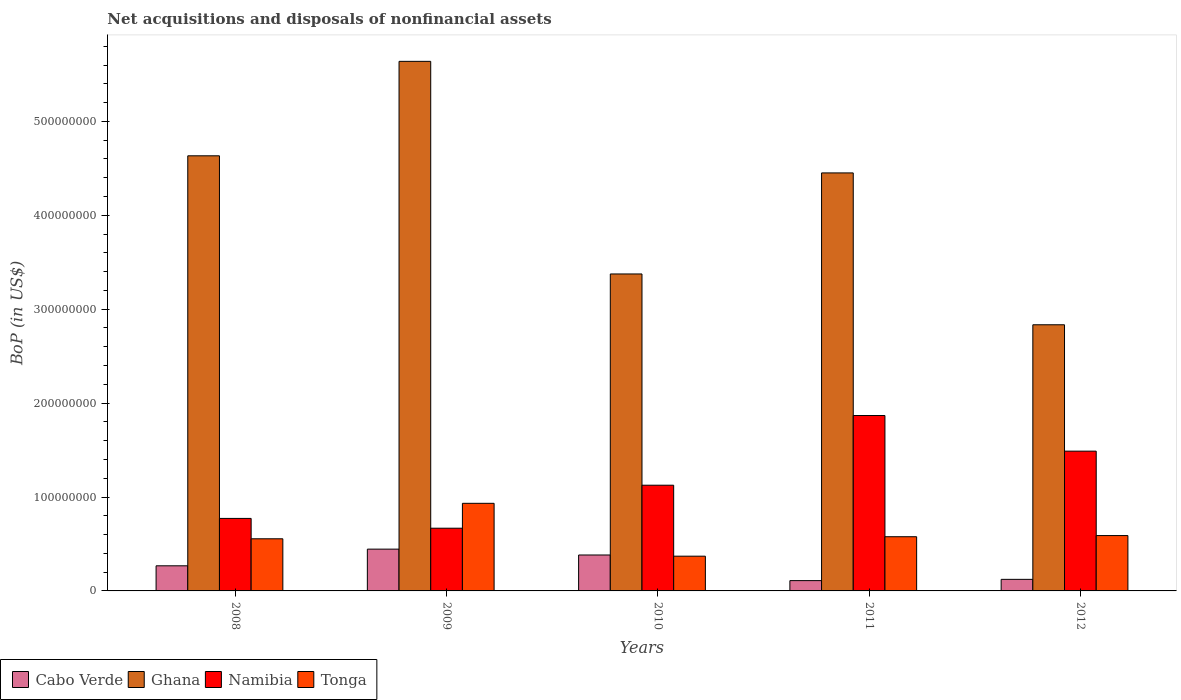How many groups of bars are there?
Your answer should be very brief. 5. How many bars are there on the 3rd tick from the left?
Your response must be concise. 4. How many bars are there on the 2nd tick from the right?
Provide a short and direct response. 4. In how many cases, is the number of bars for a given year not equal to the number of legend labels?
Provide a short and direct response. 0. What is the Balance of Payments in Tonga in 2009?
Give a very brief answer. 9.33e+07. Across all years, what is the maximum Balance of Payments in Cabo Verde?
Provide a succinct answer. 4.45e+07. Across all years, what is the minimum Balance of Payments in Tonga?
Your answer should be very brief. 3.70e+07. What is the total Balance of Payments in Cabo Verde in the graph?
Keep it short and to the point. 1.33e+08. What is the difference between the Balance of Payments in Tonga in 2009 and that in 2011?
Your response must be concise. 3.56e+07. What is the difference between the Balance of Payments in Tonga in 2010 and the Balance of Payments in Namibia in 2009?
Provide a short and direct response. -2.98e+07. What is the average Balance of Payments in Namibia per year?
Provide a short and direct response. 1.18e+08. In the year 2012, what is the difference between the Balance of Payments in Tonga and Balance of Payments in Namibia?
Provide a succinct answer. -8.99e+07. What is the ratio of the Balance of Payments in Namibia in 2008 to that in 2011?
Provide a short and direct response. 0.41. Is the Balance of Payments in Namibia in 2008 less than that in 2009?
Offer a terse response. No. What is the difference between the highest and the second highest Balance of Payments in Cabo Verde?
Provide a short and direct response. 6.24e+06. What is the difference between the highest and the lowest Balance of Payments in Namibia?
Offer a terse response. 1.20e+08. In how many years, is the Balance of Payments in Tonga greater than the average Balance of Payments in Tonga taken over all years?
Give a very brief answer. 1. Is the sum of the Balance of Payments in Cabo Verde in 2009 and 2012 greater than the maximum Balance of Payments in Namibia across all years?
Offer a terse response. No. Is it the case that in every year, the sum of the Balance of Payments in Cabo Verde and Balance of Payments in Namibia is greater than the sum of Balance of Payments in Ghana and Balance of Payments in Tonga?
Ensure brevity in your answer.  No. What does the 3rd bar from the left in 2010 represents?
Provide a short and direct response. Namibia. What does the 4th bar from the right in 2008 represents?
Your answer should be compact. Cabo Verde. How many bars are there?
Offer a very short reply. 20. Does the graph contain grids?
Provide a succinct answer. No. Where does the legend appear in the graph?
Your answer should be very brief. Bottom left. How many legend labels are there?
Provide a short and direct response. 4. How are the legend labels stacked?
Offer a terse response. Horizontal. What is the title of the graph?
Your answer should be very brief. Net acquisitions and disposals of nonfinancial assets. What is the label or title of the X-axis?
Ensure brevity in your answer.  Years. What is the label or title of the Y-axis?
Give a very brief answer. BoP (in US$). What is the BoP (in US$) of Cabo Verde in 2008?
Your answer should be compact. 2.67e+07. What is the BoP (in US$) of Ghana in 2008?
Your answer should be very brief. 4.63e+08. What is the BoP (in US$) of Namibia in 2008?
Your answer should be very brief. 7.72e+07. What is the BoP (in US$) in Tonga in 2008?
Provide a short and direct response. 5.55e+07. What is the BoP (in US$) in Cabo Verde in 2009?
Offer a terse response. 4.45e+07. What is the BoP (in US$) of Ghana in 2009?
Offer a very short reply. 5.64e+08. What is the BoP (in US$) in Namibia in 2009?
Give a very brief answer. 6.68e+07. What is the BoP (in US$) in Tonga in 2009?
Provide a short and direct response. 9.33e+07. What is the BoP (in US$) in Cabo Verde in 2010?
Keep it short and to the point. 3.83e+07. What is the BoP (in US$) of Ghana in 2010?
Your response must be concise. 3.38e+08. What is the BoP (in US$) in Namibia in 2010?
Make the answer very short. 1.13e+08. What is the BoP (in US$) in Tonga in 2010?
Offer a terse response. 3.70e+07. What is the BoP (in US$) of Cabo Verde in 2011?
Make the answer very short. 1.10e+07. What is the BoP (in US$) in Ghana in 2011?
Make the answer very short. 4.45e+08. What is the BoP (in US$) of Namibia in 2011?
Keep it short and to the point. 1.87e+08. What is the BoP (in US$) of Tonga in 2011?
Give a very brief answer. 5.77e+07. What is the BoP (in US$) in Cabo Verde in 2012?
Your answer should be compact. 1.23e+07. What is the BoP (in US$) in Ghana in 2012?
Your answer should be compact. 2.83e+08. What is the BoP (in US$) of Namibia in 2012?
Offer a terse response. 1.49e+08. What is the BoP (in US$) of Tonga in 2012?
Your response must be concise. 5.89e+07. Across all years, what is the maximum BoP (in US$) of Cabo Verde?
Keep it short and to the point. 4.45e+07. Across all years, what is the maximum BoP (in US$) of Ghana?
Your answer should be very brief. 5.64e+08. Across all years, what is the maximum BoP (in US$) of Namibia?
Provide a short and direct response. 1.87e+08. Across all years, what is the maximum BoP (in US$) in Tonga?
Make the answer very short. 9.33e+07. Across all years, what is the minimum BoP (in US$) in Cabo Verde?
Your answer should be very brief. 1.10e+07. Across all years, what is the minimum BoP (in US$) in Ghana?
Provide a succinct answer. 2.83e+08. Across all years, what is the minimum BoP (in US$) in Namibia?
Provide a succinct answer. 6.68e+07. Across all years, what is the minimum BoP (in US$) of Tonga?
Your response must be concise. 3.70e+07. What is the total BoP (in US$) of Cabo Verde in the graph?
Your answer should be compact. 1.33e+08. What is the total BoP (in US$) in Ghana in the graph?
Make the answer very short. 2.09e+09. What is the total BoP (in US$) of Namibia in the graph?
Keep it short and to the point. 5.92e+08. What is the total BoP (in US$) of Tonga in the graph?
Your answer should be compact. 3.02e+08. What is the difference between the BoP (in US$) in Cabo Verde in 2008 and that in 2009?
Keep it short and to the point. -1.77e+07. What is the difference between the BoP (in US$) in Ghana in 2008 and that in 2009?
Give a very brief answer. -1.01e+08. What is the difference between the BoP (in US$) of Namibia in 2008 and that in 2009?
Offer a terse response. 1.04e+07. What is the difference between the BoP (in US$) in Tonga in 2008 and that in 2009?
Give a very brief answer. -3.78e+07. What is the difference between the BoP (in US$) of Cabo Verde in 2008 and that in 2010?
Ensure brevity in your answer.  -1.15e+07. What is the difference between the BoP (in US$) of Ghana in 2008 and that in 2010?
Your answer should be compact. 1.26e+08. What is the difference between the BoP (in US$) of Namibia in 2008 and that in 2010?
Offer a terse response. -3.54e+07. What is the difference between the BoP (in US$) of Tonga in 2008 and that in 2010?
Give a very brief answer. 1.85e+07. What is the difference between the BoP (in US$) of Cabo Verde in 2008 and that in 2011?
Your response must be concise. 1.58e+07. What is the difference between the BoP (in US$) of Ghana in 2008 and that in 2011?
Provide a short and direct response. 1.82e+07. What is the difference between the BoP (in US$) in Namibia in 2008 and that in 2011?
Provide a short and direct response. -1.10e+08. What is the difference between the BoP (in US$) of Tonga in 2008 and that in 2011?
Make the answer very short. -2.19e+06. What is the difference between the BoP (in US$) in Cabo Verde in 2008 and that in 2012?
Your answer should be very brief. 1.44e+07. What is the difference between the BoP (in US$) of Ghana in 2008 and that in 2012?
Provide a short and direct response. 1.80e+08. What is the difference between the BoP (in US$) in Namibia in 2008 and that in 2012?
Offer a terse response. -7.16e+07. What is the difference between the BoP (in US$) in Tonga in 2008 and that in 2012?
Ensure brevity in your answer.  -3.43e+06. What is the difference between the BoP (in US$) in Cabo Verde in 2009 and that in 2010?
Ensure brevity in your answer.  6.24e+06. What is the difference between the BoP (in US$) in Ghana in 2009 and that in 2010?
Give a very brief answer. 2.26e+08. What is the difference between the BoP (in US$) in Namibia in 2009 and that in 2010?
Ensure brevity in your answer.  -4.58e+07. What is the difference between the BoP (in US$) in Tonga in 2009 and that in 2010?
Offer a very short reply. 5.63e+07. What is the difference between the BoP (in US$) in Cabo Verde in 2009 and that in 2011?
Keep it short and to the point. 3.35e+07. What is the difference between the BoP (in US$) in Ghana in 2009 and that in 2011?
Make the answer very short. 1.19e+08. What is the difference between the BoP (in US$) of Namibia in 2009 and that in 2011?
Your answer should be compact. -1.20e+08. What is the difference between the BoP (in US$) in Tonga in 2009 and that in 2011?
Ensure brevity in your answer.  3.56e+07. What is the difference between the BoP (in US$) of Cabo Verde in 2009 and that in 2012?
Offer a terse response. 3.22e+07. What is the difference between the BoP (in US$) of Ghana in 2009 and that in 2012?
Ensure brevity in your answer.  2.80e+08. What is the difference between the BoP (in US$) of Namibia in 2009 and that in 2012?
Provide a short and direct response. -8.21e+07. What is the difference between the BoP (in US$) in Tonga in 2009 and that in 2012?
Your response must be concise. 3.43e+07. What is the difference between the BoP (in US$) of Cabo Verde in 2010 and that in 2011?
Your answer should be very brief. 2.73e+07. What is the difference between the BoP (in US$) of Ghana in 2010 and that in 2011?
Your answer should be compact. -1.08e+08. What is the difference between the BoP (in US$) in Namibia in 2010 and that in 2011?
Your answer should be very brief. -7.42e+07. What is the difference between the BoP (in US$) of Tonga in 2010 and that in 2011?
Your response must be concise. -2.07e+07. What is the difference between the BoP (in US$) in Cabo Verde in 2010 and that in 2012?
Keep it short and to the point. 2.59e+07. What is the difference between the BoP (in US$) in Ghana in 2010 and that in 2012?
Your response must be concise. 5.41e+07. What is the difference between the BoP (in US$) in Namibia in 2010 and that in 2012?
Offer a terse response. -3.63e+07. What is the difference between the BoP (in US$) in Tonga in 2010 and that in 2012?
Make the answer very short. -2.20e+07. What is the difference between the BoP (in US$) of Cabo Verde in 2011 and that in 2012?
Give a very brief answer. -1.35e+06. What is the difference between the BoP (in US$) in Ghana in 2011 and that in 2012?
Your answer should be very brief. 1.62e+08. What is the difference between the BoP (in US$) in Namibia in 2011 and that in 2012?
Offer a terse response. 3.79e+07. What is the difference between the BoP (in US$) in Tonga in 2011 and that in 2012?
Offer a terse response. -1.24e+06. What is the difference between the BoP (in US$) of Cabo Verde in 2008 and the BoP (in US$) of Ghana in 2009?
Offer a terse response. -5.37e+08. What is the difference between the BoP (in US$) in Cabo Verde in 2008 and the BoP (in US$) in Namibia in 2009?
Provide a short and direct response. -4.00e+07. What is the difference between the BoP (in US$) in Cabo Verde in 2008 and the BoP (in US$) in Tonga in 2009?
Offer a very short reply. -6.65e+07. What is the difference between the BoP (in US$) of Ghana in 2008 and the BoP (in US$) of Namibia in 2009?
Ensure brevity in your answer.  3.97e+08. What is the difference between the BoP (in US$) of Ghana in 2008 and the BoP (in US$) of Tonga in 2009?
Offer a terse response. 3.70e+08. What is the difference between the BoP (in US$) in Namibia in 2008 and the BoP (in US$) in Tonga in 2009?
Your response must be concise. -1.61e+07. What is the difference between the BoP (in US$) of Cabo Verde in 2008 and the BoP (in US$) of Ghana in 2010?
Provide a short and direct response. -3.11e+08. What is the difference between the BoP (in US$) in Cabo Verde in 2008 and the BoP (in US$) in Namibia in 2010?
Offer a very short reply. -8.58e+07. What is the difference between the BoP (in US$) of Cabo Verde in 2008 and the BoP (in US$) of Tonga in 2010?
Offer a terse response. -1.02e+07. What is the difference between the BoP (in US$) in Ghana in 2008 and the BoP (in US$) in Namibia in 2010?
Make the answer very short. 3.51e+08. What is the difference between the BoP (in US$) of Ghana in 2008 and the BoP (in US$) of Tonga in 2010?
Make the answer very short. 4.26e+08. What is the difference between the BoP (in US$) of Namibia in 2008 and the BoP (in US$) of Tonga in 2010?
Your answer should be very brief. 4.02e+07. What is the difference between the BoP (in US$) of Cabo Verde in 2008 and the BoP (in US$) of Ghana in 2011?
Give a very brief answer. -4.18e+08. What is the difference between the BoP (in US$) of Cabo Verde in 2008 and the BoP (in US$) of Namibia in 2011?
Provide a succinct answer. -1.60e+08. What is the difference between the BoP (in US$) of Cabo Verde in 2008 and the BoP (in US$) of Tonga in 2011?
Provide a succinct answer. -3.10e+07. What is the difference between the BoP (in US$) of Ghana in 2008 and the BoP (in US$) of Namibia in 2011?
Ensure brevity in your answer.  2.77e+08. What is the difference between the BoP (in US$) in Ghana in 2008 and the BoP (in US$) in Tonga in 2011?
Provide a succinct answer. 4.06e+08. What is the difference between the BoP (in US$) of Namibia in 2008 and the BoP (in US$) of Tonga in 2011?
Give a very brief answer. 1.95e+07. What is the difference between the BoP (in US$) of Cabo Verde in 2008 and the BoP (in US$) of Ghana in 2012?
Your answer should be very brief. -2.57e+08. What is the difference between the BoP (in US$) of Cabo Verde in 2008 and the BoP (in US$) of Namibia in 2012?
Your answer should be compact. -1.22e+08. What is the difference between the BoP (in US$) of Cabo Verde in 2008 and the BoP (in US$) of Tonga in 2012?
Give a very brief answer. -3.22e+07. What is the difference between the BoP (in US$) in Ghana in 2008 and the BoP (in US$) in Namibia in 2012?
Your answer should be very brief. 3.14e+08. What is the difference between the BoP (in US$) of Ghana in 2008 and the BoP (in US$) of Tonga in 2012?
Keep it short and to the point. 4.04e+08. What is the difference between the BoP (in US$) in Namibia in 2008 and the BoP (in US$) in Tonga in 2012?
Offer a very short reply. 1.83e+07. What is the difference between the BoP (in US$) in Cabo Verde in 2009 and the BoP (in US$) in Ghana in 2010?
Offer a terse response. -2.93e+08. What is the difference between the BoP (in US$) of Cabo Verde in 2009 and the BoP (in US$) of Namibia in 2010?
Make the answer very short. -6.81e+07. What is the difference between the BoP (in US$) of Cabo Verde in 2009 and the BoP (in US$) of Tonga in 2010?
Your response must be concise. 7.51e+06. What is the difference between the BoP (in US$) of Ghana in 2009 and the BoP (in US$) of Namibia in 2010?
Provide a short and direct response. 4.51e+08. What is the difference between the BoP (in US$) of Ghana in 2009 and the BoP (in US$) of Tonga in 2010?
Provide a succinct answer. 5.27e+08. What is the difference between the BoP (in US$) in Namibia in 2009 and the BoP (in US$) in Tonga in 2010?
Your answer should be very brief. 2.98e+07. What is the difference between the BoP (in US$) of Cabo Verde in 2009 and the BoP (in US$) of Ghana in 2011?
Offer a terse response. -4.01e+08. What is the difference between the BoP (in US$) in Cabo Verde in 2009 and the BoP (in US$) in Namibia in 2011?
Offer a very short reply. -1.42e+08. What is the difference between the BoP (in US$) in Cabo Verde in 2009 and the BoP (in US$) in Tonga in 2011?
Provide a succinct answer. -1.32e+07. What is the difference between the BoP (in US$) in Ghana in 2009 and the BoP (in US$) in Namibia in 2011?
Offer a very short reply. 3.77e+08. What is the difference between the BoP (in US$) of Ghana in 2009 and the BoP (in US$) of Tonga in 2011?
Your answer should be compact. 5.06e+08. What is the difference between the BoP (in US$) of Namibia in 2009 and the BoP (in US$) of Tonga in 2011?
Provide a short and direct response. 9.07e+06. What is the difference between the BoP (in US$) in Cabo Verde in 2009 and the BoP (in US$) in Ghana in 2012?
Offer a very short reply. -2.39e+08. What is the difference between the BoP (in US$) in Cabo Verde in 2009 and the BoP (in US$) in Namibia in 2012?
Offer a terse response. -1.04e+08. What is the difference between the BoP (in US$) in Cabo Verde in 2009 and the BoP (in US$) in Tonga in 2012?
Offer a terse response. -1.44e+07. What is the difference between the BoP (in US$) of Ghana in 2009 and the BoP (in US$) of Namibia in 2012?
Make the answer very short. 4.15e+08. What is the difference between the BoP (in US$) in Ghana in 2009 and the BoP (in US$) in Tonga in 2012?
Give a very brief answer. 5.05e+08. What is the difference between the BoP (in US$) in Namibia in 2009 and the BoP (in US$) in Tonga in 2012?
Provide a short and direct response. 7.83e+06. What is the difference between the BoP (in US$) in Cabo Verde in 2010 and the BoP (in US$) in Ghana in 2011?
Your answer should be compact. -4.07e+08. What is the difference between the BoP (in US$) in Cabo Verde in 2010 and the BoP (in US$) in Namibia in 2011?
Your response must be concise. -1.49e+08. What is the difference between the BoP (in US$) of Cabo Verde in 2010 and the BoP (in US$) of Tonga in 2011?
Provide a succinct answer. -1.94e+07. What is the difference between the BoP (in US$) of Ghana in 2010 and the BoP (in US$) of Namibia in 2011?
Offer a terse response. 1.51e+08. What is the difference between the BoP (in US$) in Ghana in 2010 and the BoP (in US$) in Tonga in 2011?
Offer a very short reply. 2.80e+08. What is the difference between the BoP (in US$) of Namibia in 2010 and the BoP (in US$) of Tonga in 2011?
Provide a succinct answer. 5.49e+07. What is the difference between the BoP (in US$) of Cabo Verde in 2010 and the BoP (in US$) of Ghana in 2012?
Your answer should be very brief. -2.45e+08. What is the difference between the BoP (in US$) of Cabo Verde in 2010 and the BoP (in US$) of Namibia in 2012?
Offer a very short reply. -1.11e+08. What is the difference between the BoP (in US$) in Cabo Verde in 2010 and the BoP (in US$) in Tonga in 2012?
Provide a short and direct response. -2.07e+07. What is the difference between the BoP (in US$) of Ghana in 2010 and the BoP (in US$) of Namibia in 2012?
Offer a very short reply. 1.89e+08. What is the difference between the BoP (in US$) in Ghana in 2010 and the BoP (in US$) in Tonga in 2012?
Make the answer very short. 2.79e+08. What is the difference between the BoP (in US$) of Namibia in 2010 and the BoP (in US$) of Tonga in 2012?
Your answer should be very brief. 5.36e+07. What is the difference between the BoP (in US$) of Cabo Verde in 2011 and the BoP (in US$) of Ghana in 2012?
Offer a terse response. -2.72e+08. What is the difference between the BoP (in US$) in Cabo Verde in 2011 and the BoP (in US$) in Namibia in 2012?
Keep it short and to the point. -1.38e+08. What is the difference between the BoP (in US$) in Cabo Verde in 2011 and the BoP (in US$) in Tonga in 2012?
Provide a succinct answer. -4.80e+07. What is the difference between the BoP (in US$) in Ghana in 2011 and the BoP (in US$) in Namibia in 2012?
Keep it short and to the point. 2.96e+08. What is the difference between the BoP (in US$) of Ghana in 2011 and the BoP (in US$) of Tonga in 2012?
Offer a terse response. 3.86e+08. What is the difference between the BoP (in US$) of Namibia in 2011 and the BoP (in US$) of Tonga in 2012?
Keep it short and to the point. 1.28e+08. What is the average BoP (in US$) of Cabo Verde per year?
Provide a short and direct response. 2.66e+07. What is the average BoP (in US$) in Ghana per year?
Ensure brevity in your answer.  4.19e+08. What is the average BoP (in US$) of Namibia per year?
Offer a terse response. 1.18e+08. What is the average BoP (in US$) of Tonga per year?
Offer a terse response. 6.05e+07. In the year 2008, what is the difference between the BoP (in US$) in Cabo Verde and BoP (in US$) in Ghana?
Keep it short and to the point. -4.37e+08. In the year 2008, what is the difference between the BoP (in US$) in Cabo Verde and BoP (in US$) in Namibia?
Offer a terse response. -5.05e+07. In the year 2008, what is the difference between the BoP (in US$) of Cabo Verde and BoP (in US$) of Tonga?
Your answer should be compact. -2.88e+07. In the year 2008, what is the difference between the BoP (in US$) in Ghana and BoP (in US$) in Namibia?
Make the answer very short. 3.86e+08. In the year 2008, what is the difference between the BoP (in US$) of Ghana and BoP (in US$) of Tonga?
Provide a short and direct response. 4.08e+08. In the year 2008, what is the difference between the BoP (in US$) of Namibia and BoP (in US$) of Tonga?
Ensure brevity in your answer.  2.17e+07. In the year 2009, what is the difference between the BoP (in US$) in Cabo Verde and BoP (in US$) in Ghana?
Your answer should be very brief. -5.19e+08. In the year 2009, what is the difference between the BoP (in US$) of Cabo Verde and BoP (in US$) of Namibia?
Ensure brevity in your answer.  -2.23e+07. In the year 2009, what is the difference between the BoP (in US$) of Cabo Verde and BoP (in US$) of Tonga?
Your answer should be compact. -4.88e+07. In the year 2009, what is the difference between the BoP (in US$) in Ghana and BoP (in US$) in Namibia?
Your answer should be very brief. 4.97e+08. In the year 2009, what is the difference between the BoP (in US$) in Ghana and BoP (in US$) in Tonga?
Provide a short and direct response. 4.71e+08. In the year 2009, what is the difference between the BoP (in US$) in Namibia and BoP (in US$) in Tonga?
Offer a very short reply. -2.65e+07. In the year 2010, what is the difference between the BoP (in US$) of Cabo Verde and BoP (in US$) of Ghana?
Provide a succinct answer. -2.99e+08. In the year 2010, what is the difference between the BoP (in US$) of Cabo Verde and BoP (in US$) of Namibia?
Your answer should be very brief. -7.43e+07. In the year 2010, what is the difference between the BoP (in US$) of Cabo Verde and BoP (in US$) of Tonga?
Your response must be concise. 1.27e+06. In the year 2010, what is the difference between the BoP (in US$) of Ghana and BoP (in US$) of Namibia?
Make the answer very short. 2.25e+08. In the year 2010, what is the difference between the BoP (in US$) in Ghana and BoP (in US$) in Tonga?
Make the answer very short. 3.01e+08. In the year 2010, what is the difference between the BoP (in US$) in Namibia and BoP (in US$) in Tonga?
Keep it short and to the point. 7.56e+07. In the year 2011, what is the difference between the BoP (in US$) in Cabo Verde and BoP (in US$) in Ghana?
Make the answer very short. -4.34e+08. In the year 2011, what is the difference between the BoP (in US$) of Cabo Verde and BoP (in US$) of Namibia?
Your answer should be compact. -1.76e+08. In the year 2011, what is the difference between the BoP (in US$) of Cabo Verde and BoP (in US$) of Tonga?
Your response must be concise. -4.67e+07. In the year 2011, what is the difference between the BoP (in US$) of Ghana and BoP (in US$) of Namibia?
Provide a succinct answer. 2.58e+08. In the year 2011, what is the difference between the BoP (in US$) in Ghana and BoP (in US$) in Tonga?
Your answer should be very brief. 3.87e+08. In the year 2011, what is the difference between the BoP (in US$) in Namibia and BoP (in US$) in Tonga?
Provide a succinct answer. 1.29e+08. In the year 2012, what is the difference between the BoP (in US$) of Cabo Verde and BoP (in US$) of Ghana?
Make the answer very short. -2.71e+08. In the year 2012, what is the difference between the BoP (in US$) of Cabo Verde and BoP (in US$) of Namibia?
Provide a succinct answer. -1.37e+08. In the year 2012, what is the difference between the BoP (in US$) of Cabo Verde and BoP (in US$) of Tonga?
Provide a succinct answer. -4.66e+07. In the year 2012, what is the difference between the BoP (in US$) of Ghana and BoP (in US$) of Namibia?
Offer a terse response. 1.35e+08. In the year 2012, what is the difference between the BoP (in US$) of Ghana and BoP (in US$) of Tonga?
Ensure brevity in your answer.  2.24e+08. In the year 2012, what is the difference between the BoP (in US$) of Namibia and BoP (in US$) of Tonga?
Your answer should be very brief. 8.99e+07. What is the ratio of the BoP (in US$) in Cabo Verde in 2008 to that in 2009?
Offer a terse response. 0.6. What is the ratio of the BoP (in US$) of Ghana in 2008 to that in 2009?
Keep it short and to the point. 0.82. What is the ratio of the BoP (in US$) of Namibia in 2008 to that in 2009?
Give a very brief answer. 1.16. What is the ratio of the BoP (in US$) of Tonga in 2008 to that in 2009?
Provide a short and direct response. 0.6. What is the ratio of the BoP (in US$) in Cabo Verde in 2008 to that in 2010?
Your response must be concise. 0.7. What is the ratio of the BoP (in US$) of Ghana in 2008 to that in 2010?
Your answer should be compact. 1.37. What is the ratio of the BoP (in US$) of Namibia in 2008 to that in 2010?
Your response must be concise. 0.69. What is the ratio of the BoP (in US$) of Tonga in 2008 to that in 2010?
Ensure brevity in your answer.  1.5. What is the ratio of the BoP (in US$) in Cabo Verde in 2008 to that in 2011?
Your response must be concise. 2.44. What is the ratio of the BoP (in US$) of Ghana in 2008 to that in 2011?
Your answer should be compact. 1.04. What is the ratio of the BoP (in US$) of Namibia in 2008 to that in 2011?
Ensure brevity in your answer.  0.41. What is the ratio of the BoP (in US$) of Tonga in 2008 to that in 2011?
Offer a very short reply. 0.96. What is the ratio of the BoP (in US$) of Cabo Verde in 2008 to that in 2012?
Make the answer very short. 2.17. What is the ratio of the BoP (in US$) in Ghana in 2008 to that in 2012?
Ensure brevity in your answer.  1.63. What is the ratio of the BoP (in US$) in Namibia in 2008 to that in 2012?
Offer a very short reply. 0.52. What is the ratio of the BoP (in US$) in Tonga in 2008 to that in 2012?
Make the answer very short. 0.94. What is the ratio of the BoP (in US$) of Cabo Verde in 2009 to that in 2010?
Offer a very short reply. 1.16. What is the ratio of the BoP (in US$) in Ghana in 2009 to that in 2010?
Offer a very short reply. 1.67. What is the ratio of the BoP (in US$) of Namibia in 2009 to that in 2010?
Keep it short and to the point. 0.59. What is the ratio of the BoP (in US$) of Tonga in 2009 to that in 2010?
Keep it short and to the point. 2.52. What is the ratio of the BoP (in US$) in Cabo Verde in 2009 to that in 2011?
Your answer should be very brief. 4.06. What is the ratio of the BoP (in US$) of Ghana in 2009 to that in 2011?
Offer a terse response. 1.27. What is the ratio of the BoP (in US$) of Namibia in 2009 to that in 2011?
Offer a very short reply. 0.36. What is the ratio of the BoP (in US$) of Tonga in 2009 to that in 2011?
Make the answer very short. 1.62. What is the ratio of the BoP (in US$) of Cabo Verde in 2009 to that in 2012?
Keep it short and to the point. 3.61. What is the ratio of the BoP (in US$) of Ghana in 2009 to that in 2012?
Ensure brevity in your answer.  1.99. What is the ratio of the BoP (in US$) of Namibia in 2009 to that in 2012?
Your answer should be very brief. 0.45. What is the ratio of the BoP (in US$) of Tonga in 2009 to that in 2012?
Your response must be concise. 1.58. What is the ratio of the BoP (in US$) of Cabo Verde in 2010 to that in 2011?
Offer a terse response. 3.49. What is the ratio of the BoP (in US$) of Ghana in 2010 to that in 2011?
Make the answer very short. 0.76. What is the ratio of the BoP (in US$) in Namibia in 2010 to that in 2011?
Your answer should be very brief. 0.6. What is the ratio of the BoP (in US$) in Tonga in 2010 to that in 2011?
Provide a short and direct response. 0.64. What is the ratio of the BoP (in US$) of Cabo Verde in 2010 to that in 2012?
Offer a terse response. 3.11. What is the ratio of the BoP (in US$) of Ghana in 2010 to that in 2012?
Keep it short and to the point. 1.19. What is the ratio of the BoP (in US$) in Namibia in 2010 to that in 2012?
Ensure brevity in your answer.  0.76. What is the ratio of the BoP (in US$) of Tonga in 2010 to that in 2012?
Your response must be concise. 0.63. What is the ratio of the BoP (in US$) in Cabo Verde in 2011 to that in 2012?
Your answer should be very brief. 0.89. What is the ratio of the BoP (in US$) in Ghana in 2011 to that in 2012?
Provide a succinct answer. 1.57. What is the ratio of the BoP (in US$) in Namibia in 2011 to that in 2012?
Provide a short and direct response. 1.25. What is the ratio of the BoP (in US$) of Tonga in 2011 to that in 2012?
Provide a succinct answer. 0.98. What is the difference between the highest and the second highest BoP (in US$) of Cabo Verde?
Ensure brevity in your answer.  6.24e+06. What is the difference between the highest and the second highest BoP (in US$) of Ghana?
Keep it short and to the point. 1.01e+08. What is the difference between the highest and the second highest BoP (in US$) of Namibia?
Your answer should be compact. 3.79e+07. What is the difference between the highest and the second highest BoP (in US$) in Tonga?
Your answer should be very brief. 3.43e+07. What is the difference between the highest and the lowest BoP (in US$) in Cabo Verde?
Provide a short and direct response. 3.35e+07. What is the difference between the highest and the lowest BoP (in US$) of Ghana?
Your answer should be compact. 2.80e+08. What is the difference between the highest and the lowest BoP (in US$) in Namibia?
Offer a terse response. 1.20e+08. What is the difference between the highest and the lowest BoP (in US$) in Tonga?
Provide a short and direct response. 5.63e+07. 